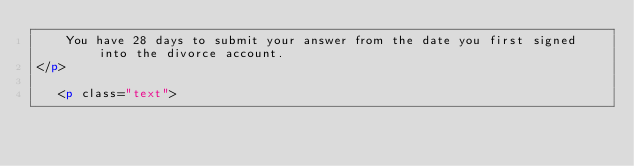Convert code to text. <code><loc_0><loc_0><loc_500><loc_500><_HTML_>    You have 28 days to submit your answer from the date you first signed into the divorce account. 
</p>

   <p class="text"></code> 